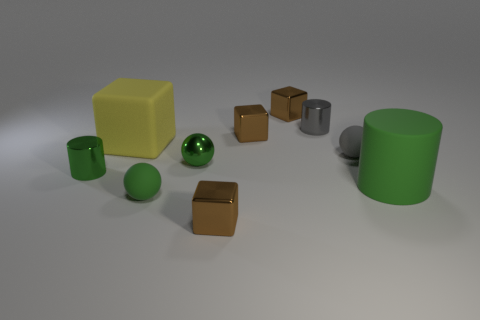Subtract all small gray cylinders. How many cylinders are left? 2 Subtract all blue balls. How many brown blocks are left? 3 Subtract 1 cubes. How many cubes are left? 3 Subtract all gray spheres. How many spheres are left? 2 Subtract all spheres. How many objects are left? 7 Add 2 tiny gray rubber things. How many tiny gray rubber things are left? 3 Add 4 green rubber things. How many green rubber things exist? 6 Subtract 0 brown cylinders. How many objects are left? 10 Subtract all purple balls. Subtract all brown cylinders. How many balls are left? 3 Subtract all small yellow cubes. Subtract all green metallic balls. How many objects are left? 9 